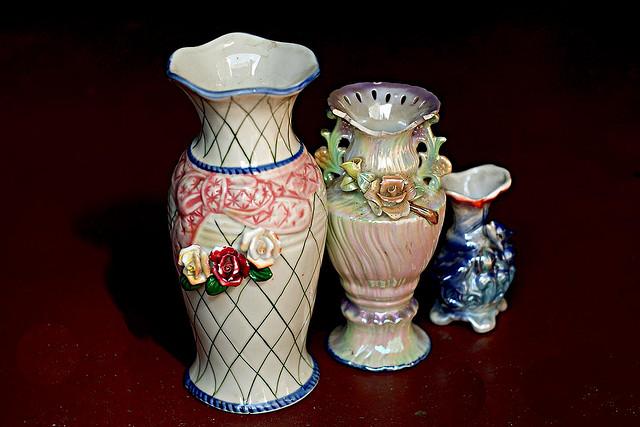How many vases on the table?
Keep it brief. 3. How many of the roses are red?
Keep it brief. 1. How are the vases similar?
Be succinct. Shape. Are these all the same?
Keep it brief. No. What are the vases made of?
Give a very brief answer. Porcelain. 